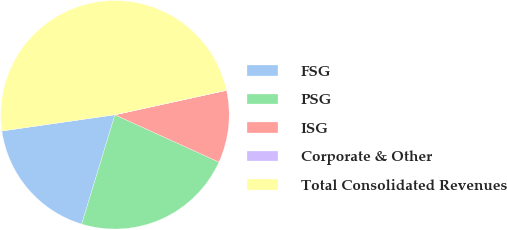Convert chart. <chart><loc_0><loc_0><loc_500><loc_500><pie_chart><fcel>FSG<fcel>PSG<fcel>ISG<fcel>Corporate & Other<fcel>Total Consolidated Revenues<nl><fcel>18.03%<fcel>22.91%<fcel>10.22%<fcel>0.01%<fcel>48.83%<nl></chart> 